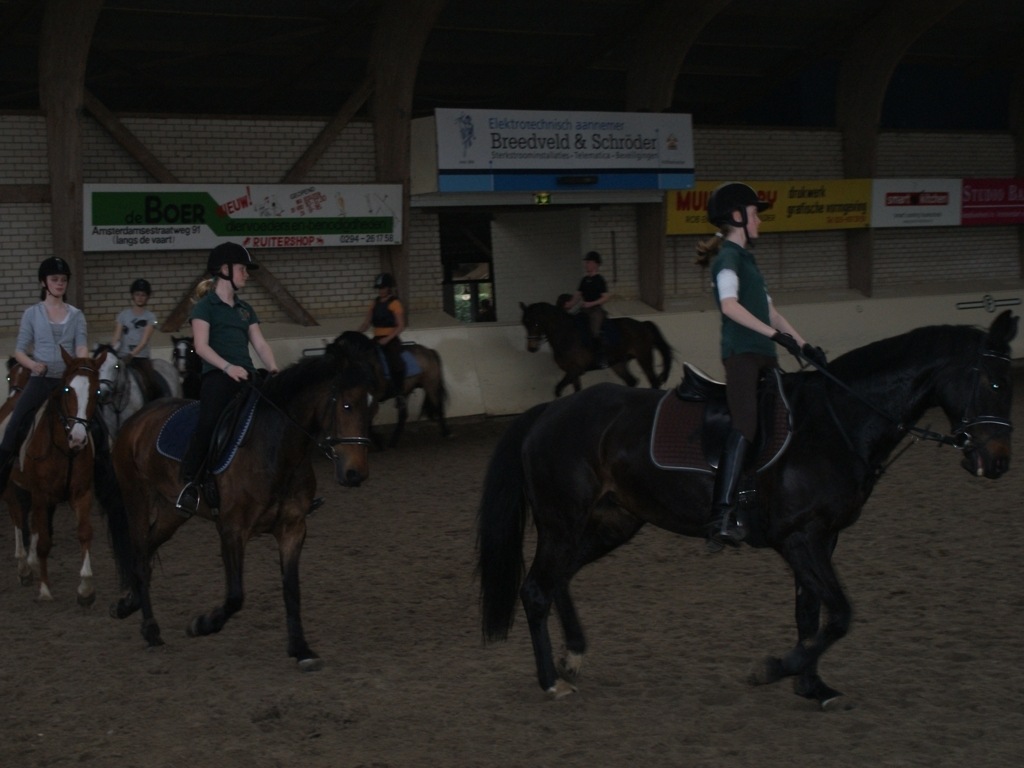How many riders can be seen in this indoor riding arena? There appear to be at least six riders visible in the indoor riding arena. What type of activity do you think they might be engaged in? Given the setting and their attire, it seems likely they are participating in a group horse riding lesson or practice session. 